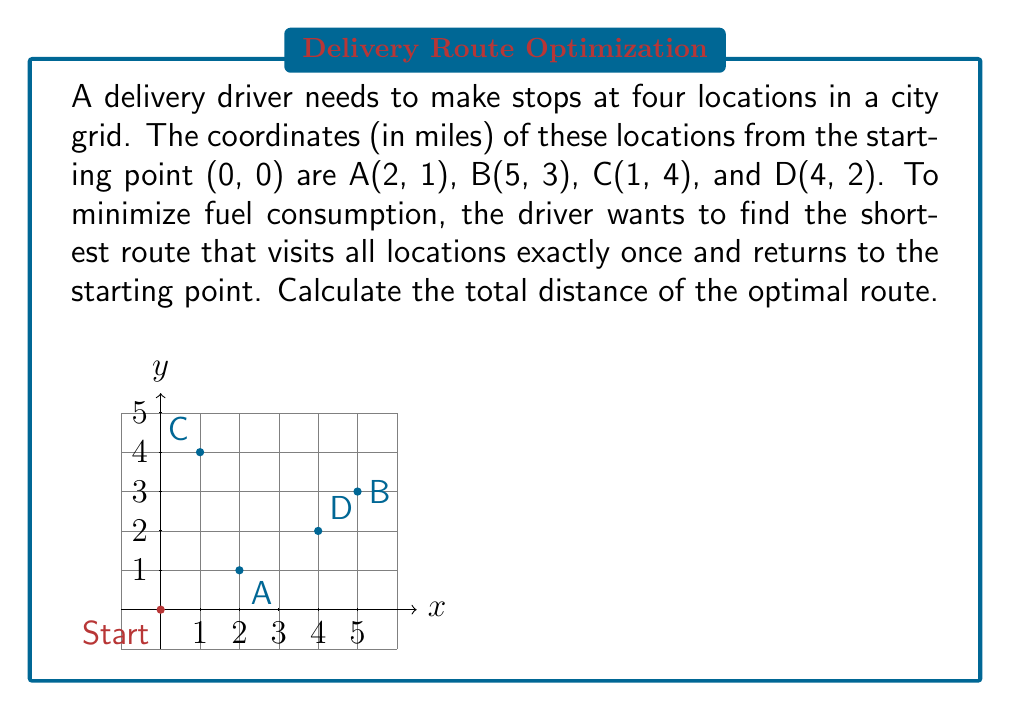Can you solve this math problem? Let's approach this problem step-by-step, using the strategy of finding the shortest path, which is analogous to minimizing fuel consumption:

1) First, we need to calculate the distances between all points, including the start/end point (0, 0). We'll use the Manhattan distance (city block distance) since the driver is moving on a grid.

   Manhattan distance formula: $d = |x_2 - x_1| + |y_2 - y_1|$

2) Calculating distances:
   Start to A: $|2-0| + |1-0| = 3$
   Start to B: $|5-0| + |3-0| = 8$
   Start to C: $|1-0| + |4-0| = 5$
   Start to D: $|4-0| + |2-0| = 6$
   A to B: $|5-2| + |3-1| = 5$
   A to C: $|1-2| + |4-1| = 4$
   A to D: $|4-2| + |2-1| = 3$
   B to C: $|1-5| + |4-3| = 5$
   B to D: $|4-5| + |2-3| = 2$
   C to D: $|4-1| + |2-4| = 5$

3) Now, we need to find the shortest route that visits all points once and returns to the start. This is known as the Traveling Salesman Problem. For a small number of points, we can check all possible routes:

   Start-A-B-C-D-Start: 3 + 5 + 5 + 5 + 6 = 24
   Start-A-B-D-C-Start: 3 + 5 + 2 + 5 + 5 = 20
   Start-A-C-B-D-Start: 3 + 4 + 5 + 2 + 6 = 20
   Start-A-C-D-B-Start: 3 + 4 + 5 + 2 + 8 = 22
   Start-A-D-B-C-Start: 3 + 3 + 2 + 5 + 5 = 18
   Start-A-D-C-B-Start: 3 + 3 + 5 + 5 + 8 = 24
   (and so on for other permutations)

4) After checking all routes, we find that the shortest path is:
   Start-A-D-B-C-Start, with a total distance of 18 miles.

This problem demonstrates how a delivery driver can use spatial intelligence and mathematical reasoning to optimize their route, minimizing fuel consumption and maximizing efficiency.
Answer: 18 miles 